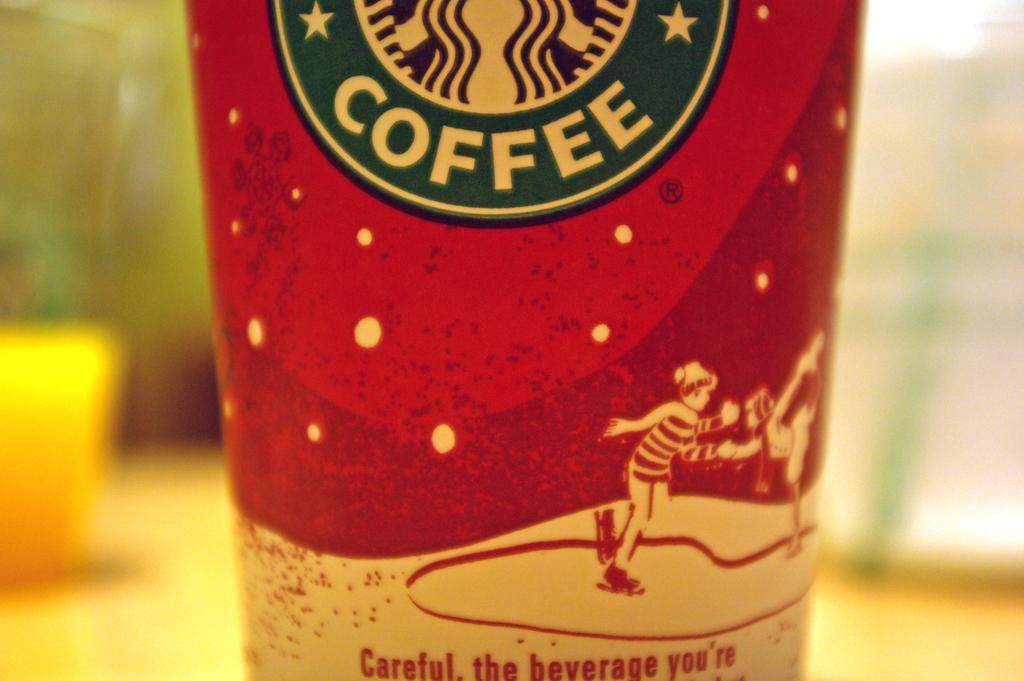<image>
Give a short and clear explanation of the subsequent image. a closeup of a red cup reading Coffee with an ice skater on it 